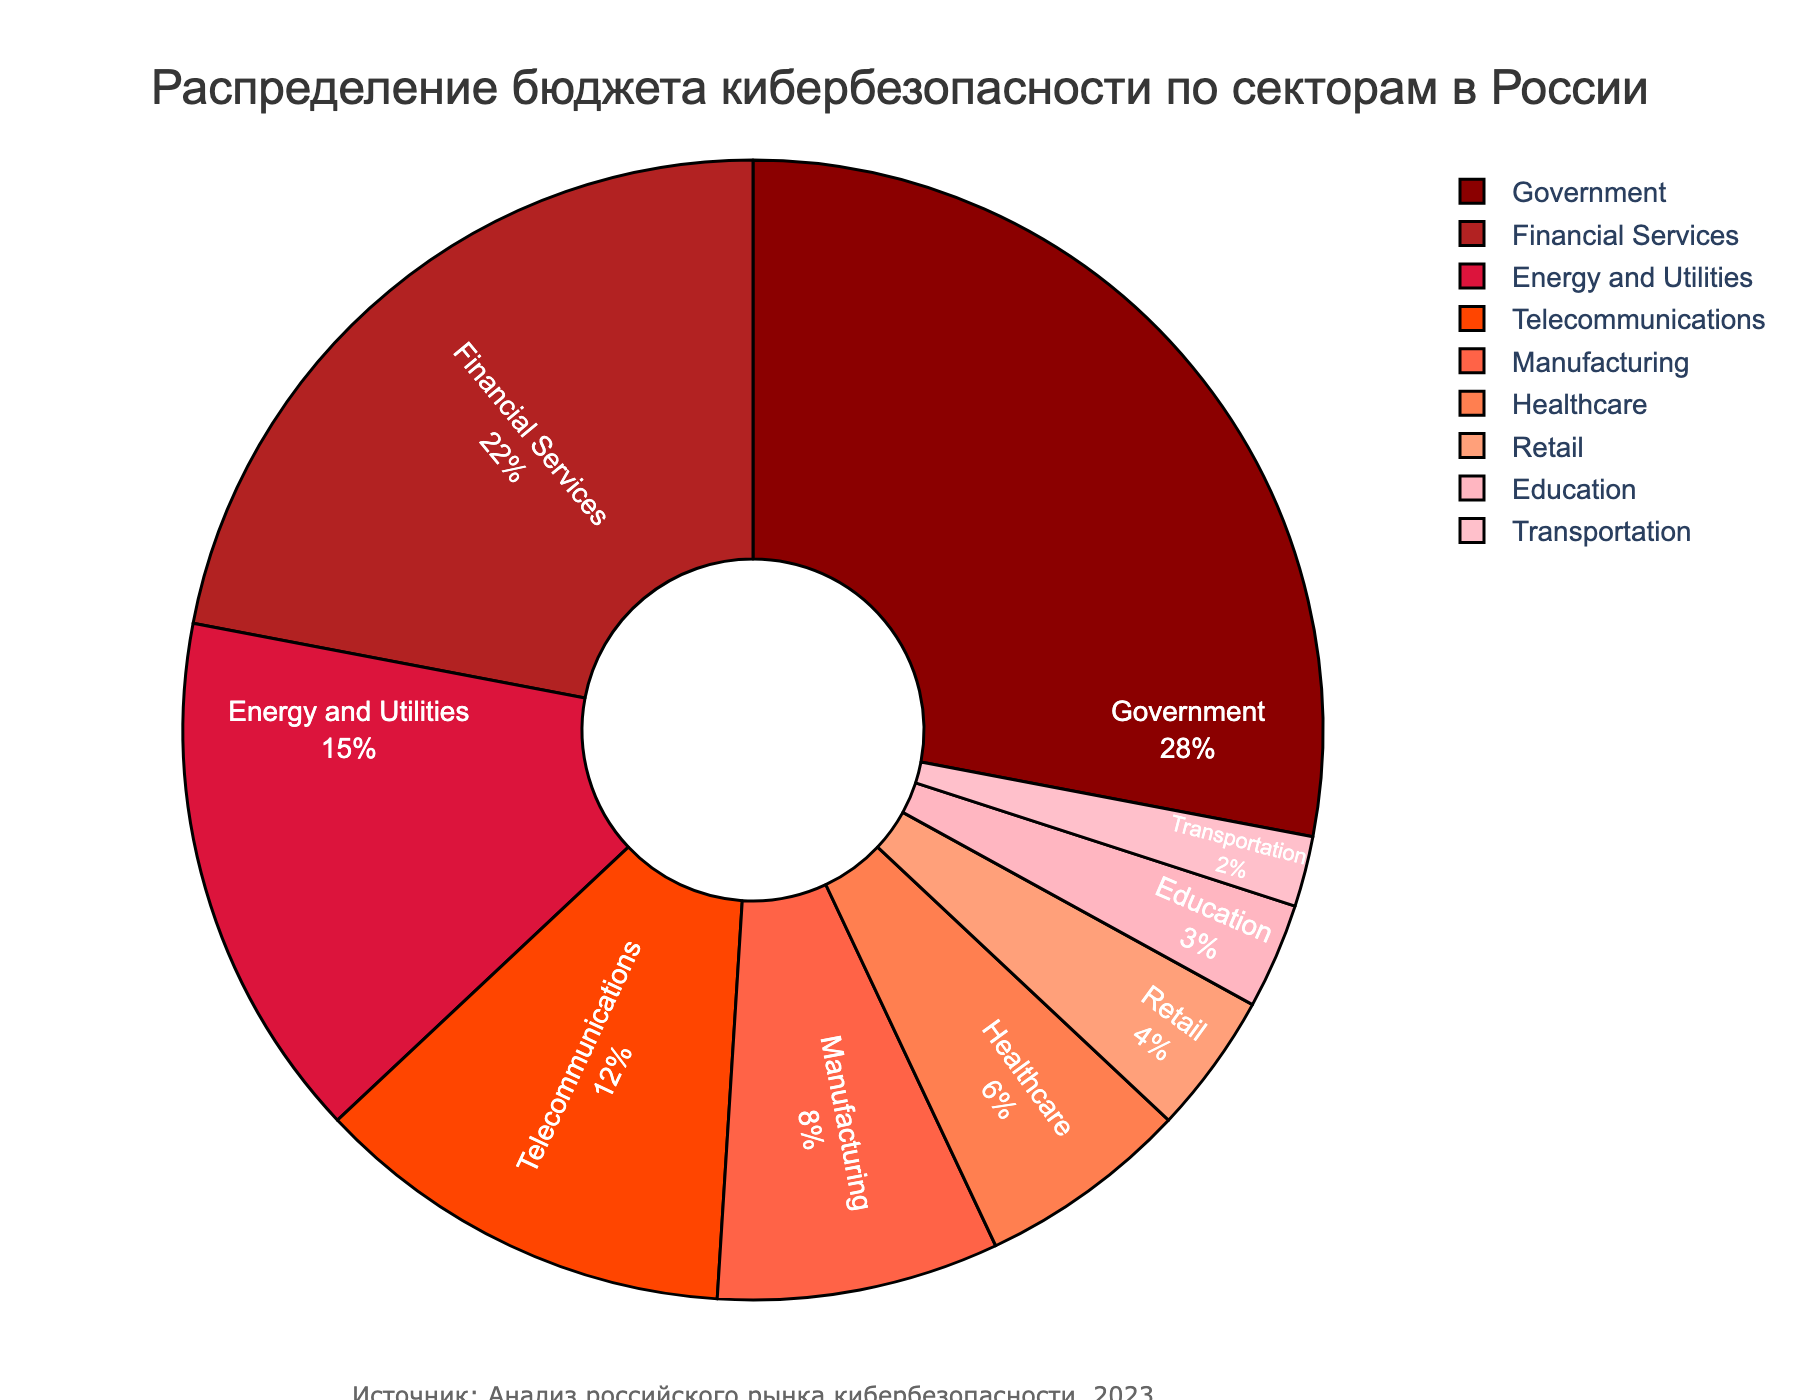What's the total budget percentage allocated to the top three sectors? The top three sectors according to budget allocation are Government (28%), Financial Services (22%), and Energy and Utilities (15%). Summing these percentages gives 28% + 22% + 15% = 65%.
Answer: 65% Which sector received the least budget allocation? By looking at the pie chart, the sector with the smallest slice is Transportation, which has a budget allocation of 2%.
Answer: Transportation What is the difference in budget allocation between the Government and Healthcare sectors? The Government sector is allocated 28%, while the Healthcare sector is allocated 6%. The difference is 28% - 6% = 22%.
Answer: 22% How much more budget percentage does the Financial Services sector have compared to the Retail sector? The Financial Services sector has 22%, and the Retail sector has 4%. The difference is 22% - 4% = 18%.
Answer: 18% Which sector is represented by the largest slice in the pie chart? The largest slice in the pie chart belongs to the Government sector, which has 28%.
Answer: Government What percentage of the budget is allocated to sectors categorized as below 10% individually (Manufacturing, Healthcare, Retail, Education, Transportation)? These sectors and their budget allocations are Manufacturing (8%), Healthcare (6%), Retail (4%), Education (3%), and Transportation (2%). Summing these percentages gives 8% + 6% + 4% + 3% + 2% = 23%.
Answer: 23% Which sector's budget percentage is exactly half of the Government's sector budget percentage? The Government sector's budget percentage is 28%, so half of it would be 28% / 2 = 14%. The closest sector to this value is Energy and Utilities, which has 15%, but none are exactly 14%. Therefore, none match exactly.
Answer: None List the sectors whose budget allocation is less than the average budget allocation. The total budget allocation is 100%, and there are 9 sectors. Thus, the average is 100% / 9 ≈ 11.11%. The sectors below this average are Telecommunications (12%), Manufacturing (8%), Healthcare (6%), Retail (4%), Education (3%), and Transportation (2%). Note that Telecommunications is slightly above the average.
Answer: Manufacturing, Healthcare, Retail, Education, Transportation Is the total budget allocation for the Financial Services and Energy and Utilities sectors greater than that for the Government sector? The Financial Services sector has 22%, and the Energy and Utilities sector has 15%. Their total is 22% + 15% = 37%. The Government sector alone has 28%. Therefore, 37% (22% + 15%) is greater than 28%.
Answer: Yes 